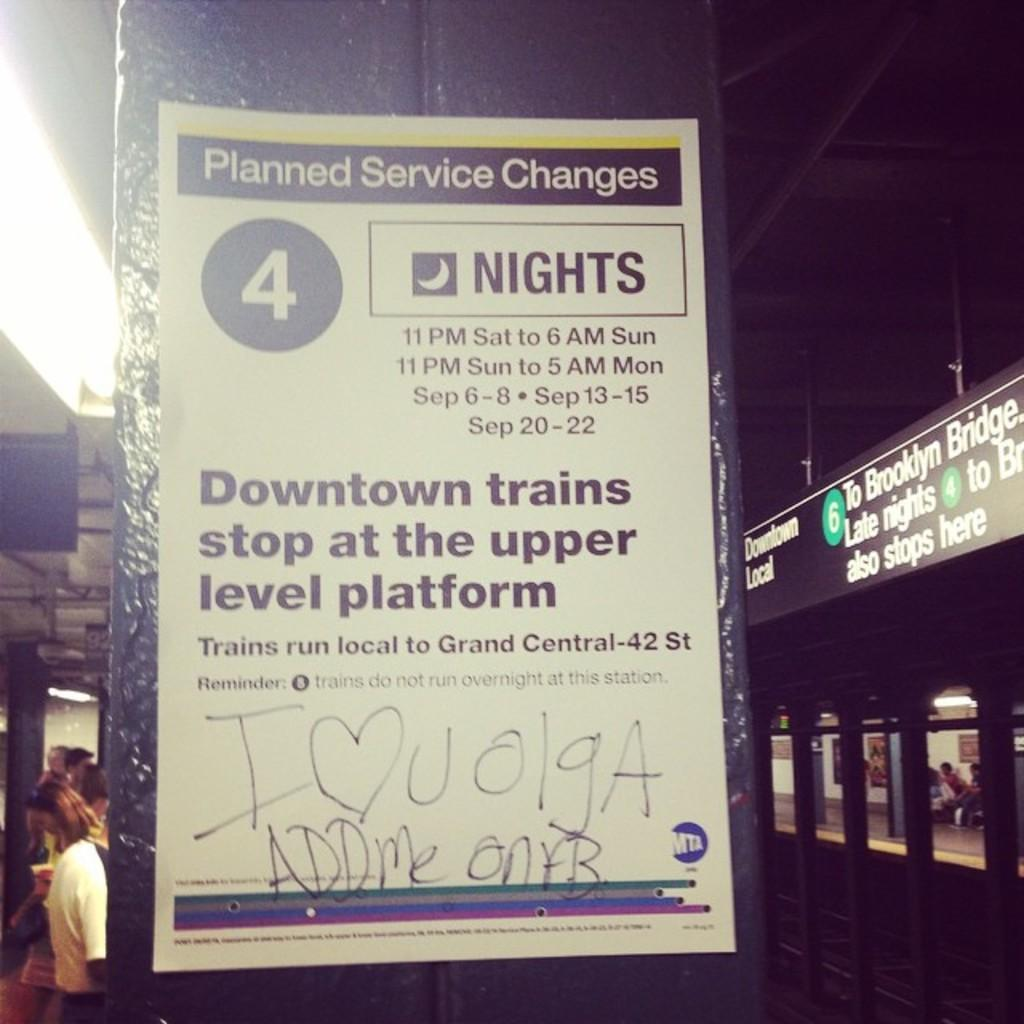What is attached to the wall in the image? There is a paper pasted on the wall in the image. What type of content is on the paper? The paper is an advertisement. What type of flame can be seen on the paper in the image? There is no flame present on the paper in the image; it is an advertisement. 